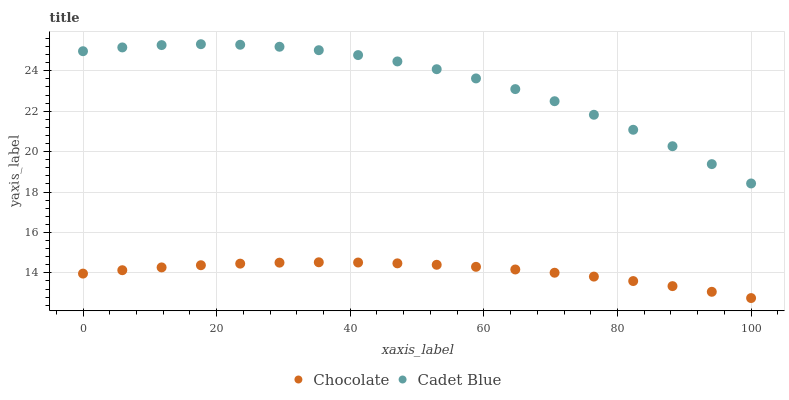Does Chocolate have the minimum area under the curve?
Answer yes or no. Yes. Does Cadet Blue have the maximum area under the curve?
Answer yes or no. Yes. Does Chocolate have the maximum area under the curve?
Answer yes or no. No. Is Chocolate the smoothest?
Answer yes or no. Yes. Is Cadet Blue the roughest?
Answer yes or no. Yes. Is Chocolate the roughest?
Answer yes or no. No. Does Chocolate have the lowest value?
Answer yes or no. Yes. Does Cadet Blue have the highest value?
Answer yes or no. Yes. Does Chocolate have the highest value?
Answer yes or no. No. Is Chocolate less than Cadet Blue?
Answer yes or no. Yes. Is Cadet Blue greater than Chocolate?
Answer yes or no. Yes. Does Chocolate intersect Cadet Blue?
Answer yes or no. No. 